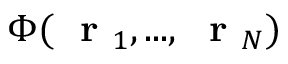<formula> <loc_0><loc_0><loc_500><loc_500>\Phi ( r _ { 1 } , \dots , r _ { N } )</formula> 